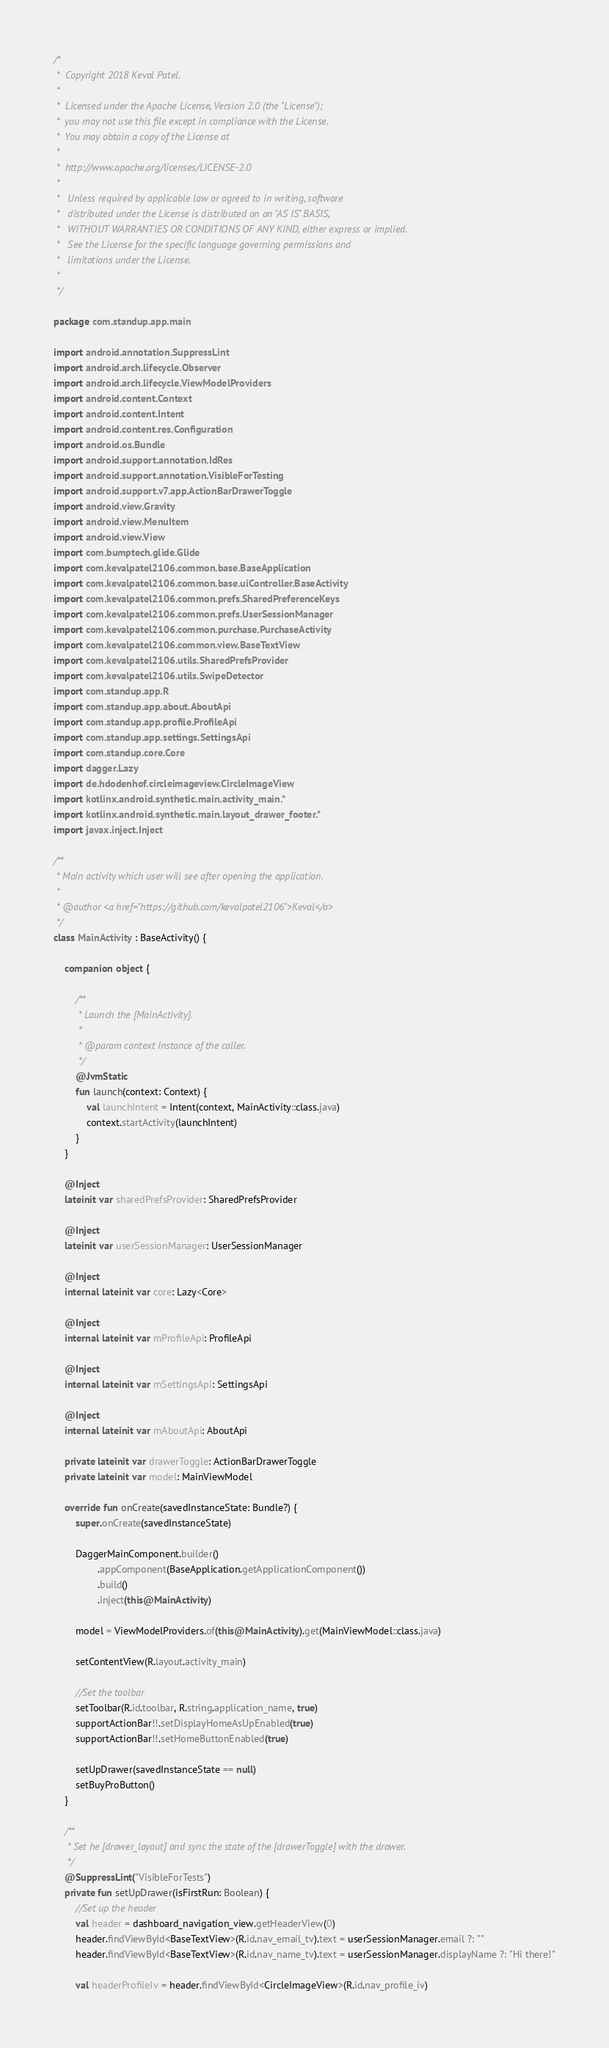Convert code to text. <code><loc_0><loc_0><loc_500><loc_500><_Kotlin_>/*
 *  Copyright 2018 Keval Patel.
 *
 *  Licensed under the Apache License, Version 2.0 (the "License");
 *  you may not use this file except in compliance with the License.
 *  You may obtain a copy of the License at
 *
 *  http://www.apache.org/licenses/LICENSE-2.0
 *
 *   Unless required by applicable law or agreed to in writing, software
 *   distributed under the License is distributed on an "AS IS" BASIS,
 *   WITHOUT WARRANTIES OR CONDITIONS OF ANY KIND, either express or implied.
 *   See the License for the specific language governing permissions and
 *   limitations under the License.
 *
 */

package com.standup.app.main

import android.annotation.SuppressLint
import android.arch.lifecycle.Observer
import android.arch.lifecycle.ViewModelProviders
import android.content.Context
import android.content.Intent
import android.content.res.Configuration
import android.os.Bundle
import android.support.annotation.IdRes
import android.support.annotation.VisibleForTesting
import android.support.v7.app.ActionBarDrawerToggle
import android.view.Gravity
import android.view.MenuItem
import android.view.View
import com.bumptech.glide.Glide
import com.kevalpatel2106.common.base.BaseApplication
import com.kevalpatel2106.common.base.uiController.BaseActivity
import com.kevalpatel2106.common.prefs.SharedPreferenceKeys
import com.kevalpatel2106.common.prefs.UserSessionManager
import com.kevalpatel2106.common.purchase.PurchaseActivity
import com.kevalpatel2106.common.view.BaseTextView
import com.kevalpatel2106.utils.SharedPrefsProvider
import com.kevalpatel2106.utils.SwipeDetector
import com.standup.app.R
import com.standup.app.about.AboutApi
import com.standup.app.profile.ProfileApi
import com.standup.app.settings.SettingsApi
import com.standup.core.Core
import dagger.Lazy
import de.hdodenhof.circleimageview.CircleImageView
import kotlinx.android.synthetic.main.activity_main.*
import kotlinx.android.synthetic.main.layout_drawer_footer.*
import javax.inject.Inject

/**
 * Main activity which user will see after opening the application.
 *
 * @author <a href="https://github.com/kevalpatel2106">Keval</a>
 */
class MainActivity : BaseActivity() {

    companion object {

        /**
         * Launch the [MainActivity].
         *
         * @param context Instance of the caller.
         */
        @JvmStatic
        fun launch(context: Context) {
            val launchIntent = Intent(context, MainActivity::class.java)
            context.startActivity(launchIntent)
        }
    }

    @Inject
    lateinit var sharedPrefsProvider: SharedPrefsProvider

    @Inject
    lateinit var userSessionManager: UserSessionManager

    @Inject
    internal lateinit var core: Lazy<Core>

    @Inject
    internal lateinit var mProfileApi: ProfileApi

    @Inject
    internal lateinit var mSettingsApi: SettingsApi

    @Inject
    internal lateinit var mAboutApi: AboutApi

    private lateinit var drawerToggle: ActionBarDrawerToggle
    private lateinit var model: MainViewModel

    override fun onCreate(savedInstanceState: Bundle?) {
        super.onCreate(savedInstanceState)

        DaggerMainComponent.builder()
                .appComponent(BaseApplication.getApplicationComponent())
                .build()
                .inject(this@MainActivity)

        model = ViewModelProviders.of(this@MainActivity).get(MainViewModel::class.java)

        setContentView(R.layout.activity_main)

        //Set the toolbar
        setToolbar(R.id.toolbar, R.string.application_name, true)
        supportActionBar!!.setDisplayHomeAsUpEnabled(true)
        supportActionBar!!.setHomeButtonEnabled(true)

        setUpDrawer(savedInstanceState == null)
        setBuyProButton()
    }

    /**
     * Set he [drawer_layout] and sync the state of the [drawerToggle] with the drawer.
     */
    @SuppressLint("VisibleForTests")
    private fun setUpDrawer(isFirstRun: Boolean) {
        //Set up the header
        val header = dashboard_navigation_view.getHeaderView(0)
        header.findViewById<BaseTextView>(R.id.nav_email_tv).text = userSessionManager.email ?: ""
        header.findViewById<BaseTextView>(R.id.nav_name_tv).text = userSessionManager.displayName ?: "Hi there!"

        val headerProfileIv = header.findViewById<CircleImageView>(R.id.nav_profile_iv)</code> 